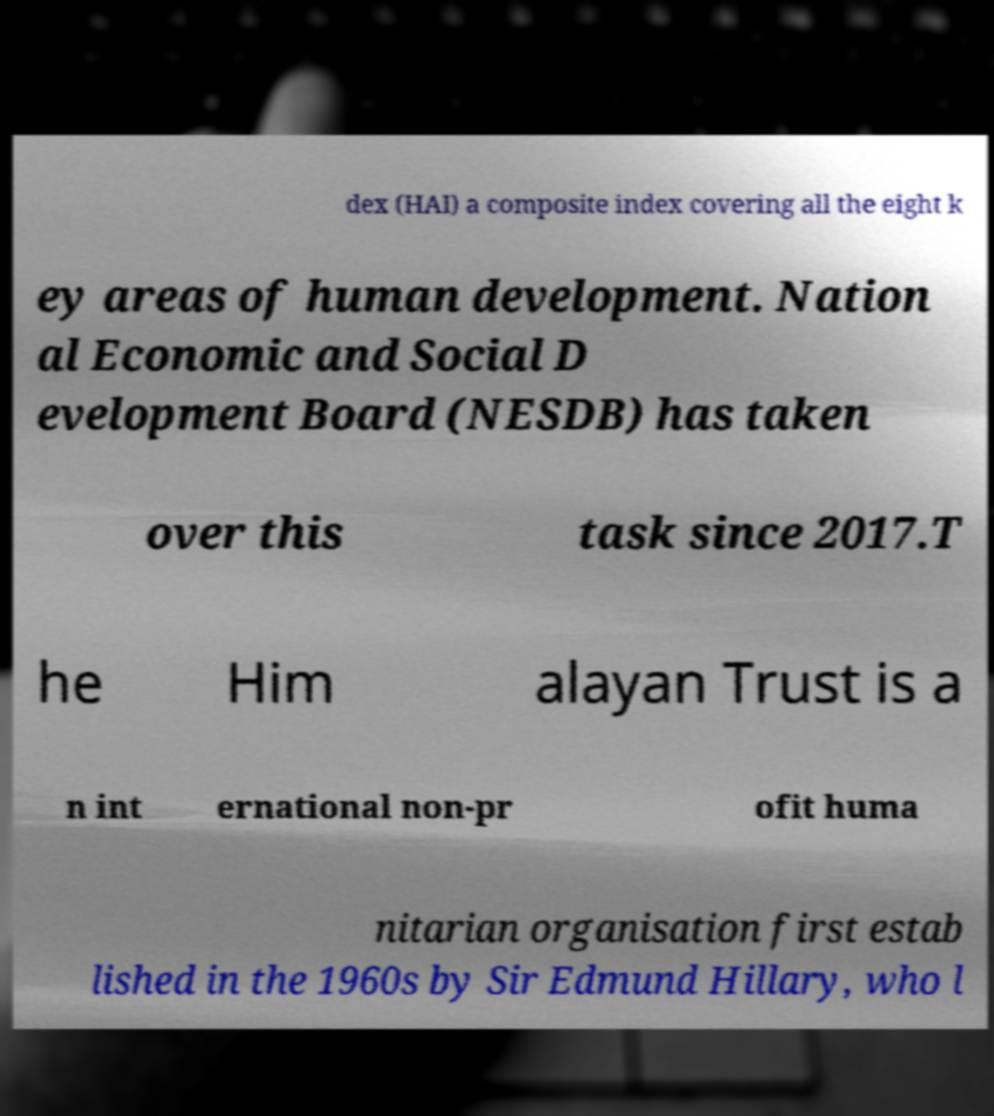There's text embedded in this image that I need extracted. Can you transcribe it verbatim? dex (HAI) a composite index covering all the eight k ey areas of human development. Nation al Economic and Social D evelopment Board (NESDB) has taken over this task since 2017.T he Him alayan Trust is a n int ernational non-pr ofit huma nitarian organisation first estab lished in the 1960s by Sir Edmund Hillary, who l 